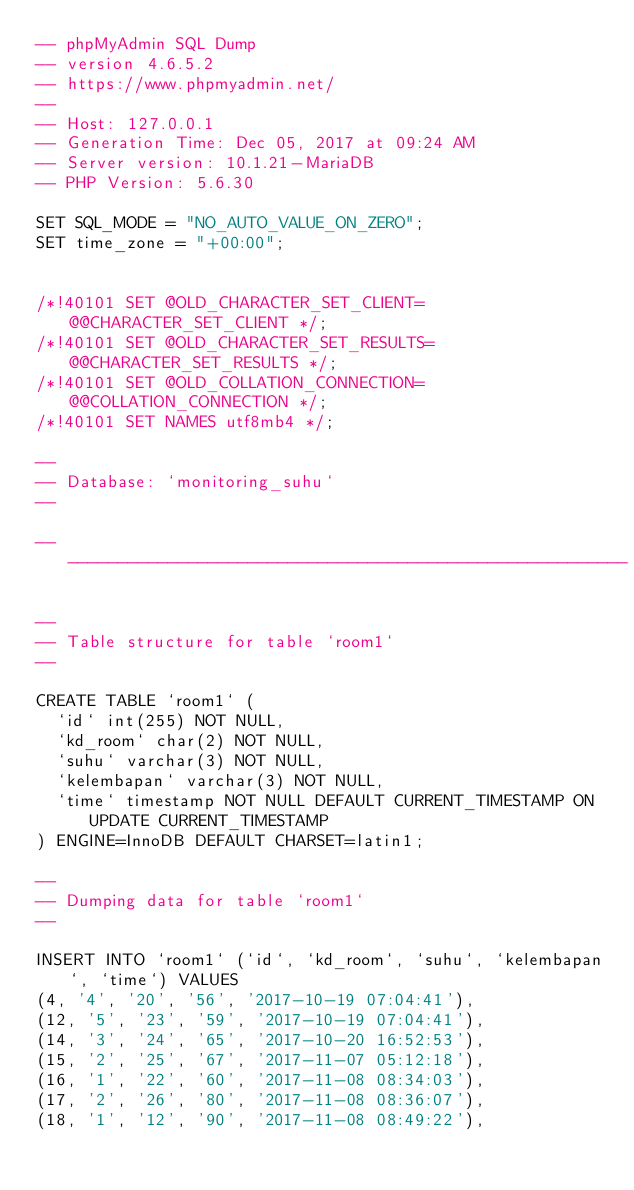Convert code to text. <code><loc_0><loc_0><loc_500><loc_500><_SQL_>-- phpMyAdmin SQL Dump
-- version 4.6.5.2
-- https://www.phpmyadmin.net/
--
-- Host: 127.0.0.1
-- Generation Time: Dec 05, 2017 at 09:24 AM
-- Server version: 10.1.21-MariaDB
-- PHP Version: 5.6.30

SET SQL_MODE = "NO_AUTO_VALUE_ON_ZERO";
SET time_zone = "+00:00";


/*!40101 SET @OLD_CHARACTER_SET_CLIENT=@@CHARACTER_SET_CLIENT */;
/*!40101 SET @OLD_CHARACTER_SET_RESULTS=@@CHARACTER_SET_RESULTS */;
/*!40101 SET @OLD_COLLATION_CONNECTION=@@COLLATION_CONNECTION */;
/*!40101 SET NAMES utf8mb4 */;

--
-- Database: `monitoring_suhu`
--

-- --------------------------------------------------------

--
-- Table structure for table `room1`
--

CREATE TABLE `room1` (
  `id` int(255) NOT NULL,
  `kd_room` char(2) NOT NULL,
  `suhu` varchar(3) NOT NULL,
  `kelembapan` varchar(3) NOT NULL,
  `time` timestamp NOT NULL DEFAULT CURRENT_TIMESTAMP ON UPDATE CURRENT_TIMESTAMP
) ENGINE=InnoDB DEFAULT CHARSET=latin1;

--
-- Dumping data for table `room1`
--

INSERT INTO `room1` (`id`, `kd_room`, `suhu`, `kelembapan`, `time`) VALUES
(4, '4', '20', '56', '2017-10-19 07:04:41'),
(12, '5', '23', '59', '2017-10-19 07:04:41'),
(14, '3', '24', '65', '2017-10-20 16:52:53'),
(15, '2', '25', '67', '2017-11-07 05:12:18'),
(16, '1', '22', '60', '2017-11-08 08:34:03'),
(17, '2', '26', '80', '2017-11-08 08:36:07'),
(18, '1', '12', '90', '2017-11-08 08:49:22'),</code> 